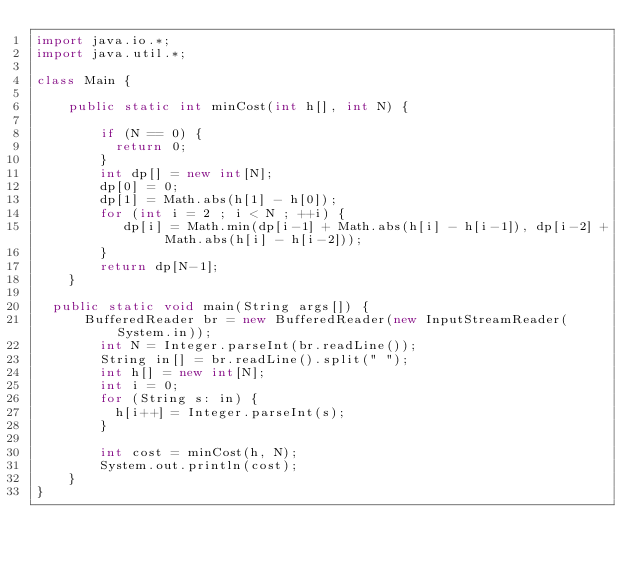<code> <loc_0><loc_0><loc_500><loc_500><_Java_>import java.io.*;
import java.util.*;

class Main {
  
  	public static int minCost(int h[], int N) {
      
      	if (N == 0) {
        	return 0;
        }
      	int dp[] = new int[N];
      	dp[0] = 0;
      	dp[1] = Math.abs(h[1] - h[0]);
      	for (int i = 2 ; i < N ; ++i) {
         	 dp[i] = Math.min(dp[i-1] + Math.abs(h[i] - h[i-1]), dp[i-2] + Math.abs(h[i] - h[i-2]));
        }
      	return dp[N-1];
    }
      
	public static void main(String args[]) {
     	BufferedReader br = new BufferedReader(new InputStreamReader(System.in));
      	int N = Integer.parseInt(br.readLine());
      	String in[] = br.readLine().split(" ");
      	int h[] = new int[N];
      	int i = 0;
      	for (String s: in) {
        	h[i++] = Integer.parseInt(s);
        }
      
      	int cost = minCost(h, N);
      	System.out.println(cost);
    }
}</code> 